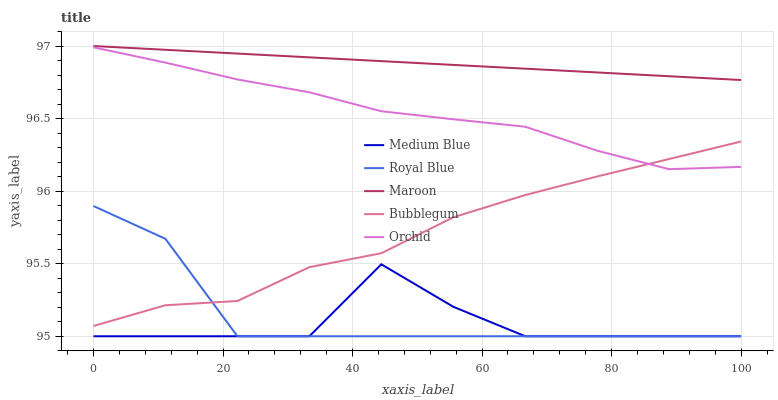Does Medium Blue have the minimum area under the curve?
Answer yes or no. Yes. Does Maroon have the maximum area under the curve?
Answer yes or no. Yes. Does Bubblegum have the minimum area under the curve?
Answer yes or no. No. Does Bubblegum have the maximum area under the curve?
Answer yes or no. No. Is Maroon the smoothest?
Answer yes or no. Yes. Is Medium Blue the roughest?
Answer yes or no. Yes. Is Bubblegum the smoothest?
Answer yes or no. No. Is Bubblegum the roughest?
Answer yes or no. No. Does Royal Blue have the lowest value?
Answer yes or no. Yes. Does Bubblegum have the lowest value?
Answer yes or no. No. Does Maroon have the highest value?
Answer yes or no. Yes. Does Bubblegum have the highest value?
Answer yes or no. No. Is Medium Blue less than Orchid?
Answer yes or no. Yes. Is Maroon greater than Orchid?
Answer yes or no. Yes. Does Orchid intersect Bubblegum?
Answer yes or no. Yes. Is Orchid less than Bubblegum?
Answer yes or no. No. Is Orchid greater than Bubblegum?
Answer yes or no. No. Does Medium Blue intersect Orchid?
Answer yes or no. No. 